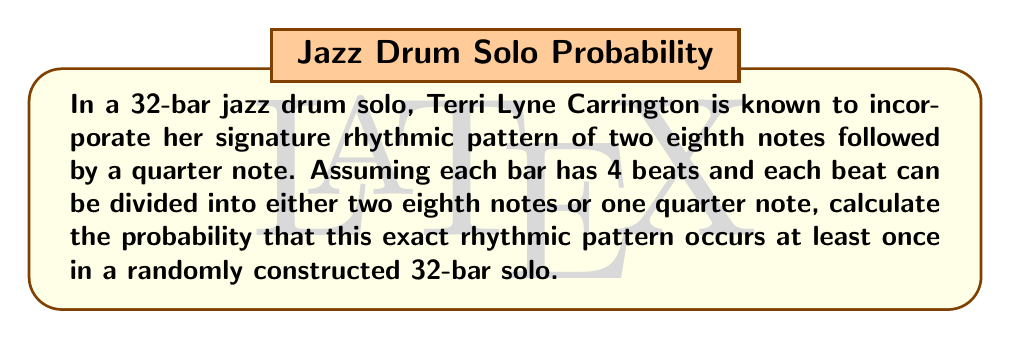Could you help me with this problem? Let's approach this step-by-step:

1) First, let's calculate the number of possible ways to fill one beat:
   - One quarter note: 1 way
   - Two eighth notes: 1 way
   Total: 2 ways per beat

2) In one bar (4 beats), we have: $2^4 = 16$ possible combinations

3) The signature pattern (two eighth notes + quarter note) takes up 2 beats. So, in each bar, there are 3 possible starting positions for this pattern:
   - Beats 1-2
   - Beats 2-3
   - Beats 3-4

4) The probability of the pattern NOT occurring in a specific 2-beat position is:
   $P(\text{no pattern}) = 1 - \frac{1}{2^2} = \frac{3}{4}$

5) For the pattern to not occur in a bar, it must not occur in any of the 3 possible positions:
   $P(\text{no pattern in bar}) = (\frac{3}{4})^3 = \frac{27}{64}$

6) For the pattern to not occur in the entire 32-bar solo, it must not occur in any of the 32 bars:
   $P(\text{no pattern in solo}) = (\frac{27}{64})^{32}$

7) Therefore, the probability of the pattern occurring at least once is:
   $P(\text{pattern occurs}) = 1 - (\frac{27}{64})^{32}$

8) Calculating this:
   $P(\text{pattern occurs}) = 1 - (0.421875)^{32} \approx 0.9999999999999999999999$
Answer: $$1 - (\frac{27}{64})^{32} \approx 0.9999999999999999999999$$ 